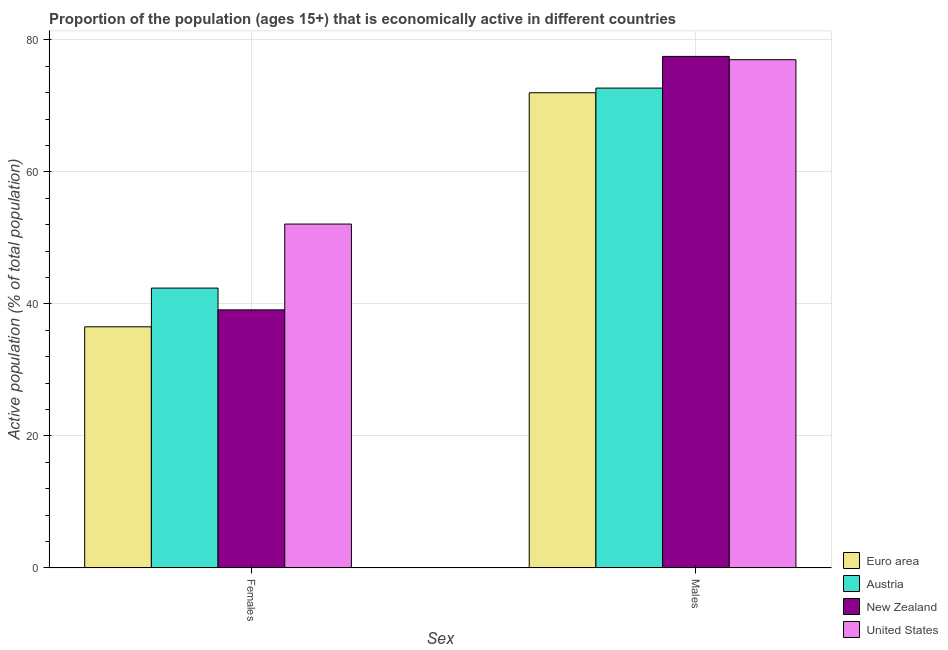How many different coloured bars are there?
Give a very brief answer. 4. How many bars are there on the 1st tick from the left?
Provide a short and direct response. 4. How many bars are there on the 2nd tick from the right?
Offer a terse response. 4. What is the label of the 1st group of bars from the left?
Make the answer very short. Females. What is the percentage of economically active female population in Euro area?
Your response must be concise. 36.53. Across all countries, what is the maximum percentage of economically active female population?
Make the answer very short. 52.1. Across all countries, what is the minimum percentage of economically active female population?
Keep it short and to the point. 36.53. What is the total percentage of economically active male population in the graph?
Make the answer very short. 299.19. What is the difference between the percentage of economically active male population in Euro area and that in New Zealand?
Give a very brief answer. -5.51. What is the difference between the percentage of economically active female population in United States and the percentage of economically active male population in Euro area?
Give a very brief answer. -19.89. What is the average percentage of economically active female population per country?
Make the answer very short. 42.53. What is the difference between the percentage of economically active male population and percentage of economically active female population in United States?
Your answer should be compact. 24.9. What is the ratio of the percentage of economically active female population in Euro area to that in Austria?
Give a very brief answer. 0.86. Is the percentage of economically active male population in United States less than that in New Zealand?
Your answer should be very brief. Yes. What does the 1st bar from the left in Males represents?
Your response must be concise. Euro area. What does the 1st bar from the right in Females represents?
Make the answer very short. United States. How many countries are there in the graph?
Make the answer very short. 4. What is the difference between two consecutive major ticks on the Y-axis?
Your response must be concise. 20. Are the values on the major ticks of Y-axis written in scientific E-notation?
Provide a short and direct response. No. Does the graph contain grids?
Offer a terse response. Yes. How many legend labels are there?
Your response must be concise. 4. How are the legend labels stacked?
Make the answer very short. Vertical. What is the title of the graph?
Offer a terse response. Proportion of the population (ages 15+) that is economically active in different countries. What is the label or title of the X-axis?
Provide a short and direct response. Sex. What is the label or title of the Y-axis?
Provide a short and direct response. Active population (% of total population). What is the Active population (% of total population) in Euro area in Females?
Your response must be concise. 36.53. What is the Active population (% of total population) of Austria in Females?
Ensure brevity in your answer.  42.4. What is the Active population (% of total population) of New Zealand in Females?
Make the answer very short. 39.1. What is the Active population (% of total population) of United States in Females?
Provide a succinct answer. 52.1. What is the Active population (% of total population) in Euro area in Males?
Ensure brevity in your answer.  71.99. What is the Active population (% of total population) in Austria in Males?
Make the answer very short. 72.7. What is the Active population (% of total population) in New Zealand in Males?
Provide a short and direct response. 77.5. What is the Active population (% of total population) of United States in Males?
Your response must be concise. 77. Across all Sex, what is the maximum Active population (% of total population) in Euro area?
Provide a succinct answer. 71.99. Across all Sex, what is the maximum Active population (% of total population) in Austria?
Your answer should be compact. 72.7. Across all Sex, what is the maximum Active population (% of total population) of New Zealand?
Offer a very short reply. 77.5. Across all Sex, what is the maximum Active population (% of total population) of United States?
Provide a short and direct response. 77. Across all Sex, what is the minimum Active population (% of total population) of Euro area?
Make the answer very short. 36.53. Across all Sex, what is the minimum Active population (% of total population) in Austria?
Keep it short and to the point. 42.4. Across all Sex, what is the minimum Active population (% of total population) of New Zealand?
Offer a very short reply. 39.1. Across all Sex, what is the minimum Active population (% of total population) of United States?
Your answer should be compact. 52.1. What is the total Active population (% of total population) of Euro area in the graph?
Offer a very short reply. 108.53. What is the total Active population (% of total population) in Austria in the graph?
Provide a short and direct response. 115.1. What is the total Active population (% of total population) in New Zealand in the graph?
Provide a short and direct response. 116.6. What is the total Active population (% of total population) of United States in the graph?
Offer a terse response. 129.1. What is the difference between the Active population (% of total population) in Euro area in Females and that in Males?
Keep it short and to the point. -35.46. What is the difference between the Active population (% of total population) in Austria in Females and that in Males?
Ensure brevity in your answer.  -30.3. What is the difference between the Active population (% of total population) of New Zealand in Females and that in Males?
Provide a succinct answer. -38.4. What is the difference between the Active population (% of total population) in United States in Females and that in Males?
Keep it short and to the point. -24.9. What is the difference between the Active population (% of total population) of Euro area in Females and the Active population (% of total population) of Austria in Males?
Provide a succinct answer. -36.17. What is the difference between the Active population (% of total population) in Euro area in Females and the Active population (% of total population) in New Zealand in Males?
Your response must be concise. -40.97. What is the difference between the Active population (% of total population) in Euro area in Females and the Active population (% of total population) in United States in Males?
Offer a very short reply. -40.47. What is the difference between the Active population (% of total population) of Austria in Females and the Active population (% of total population) of New Zealand in Males?
Ensure brevity in your answer.  -35.1. What is the difference between the Active population (% of total population) of Austria in Females and the Active population (% of total population) of United States in Males?
Keep it short and to the point. -34.6. What is the difference between the Active population (% of total population) of New Zealand in Females and the Active population (% of total population) of United States in Males?
Make the answer very short. -37.9. What is the average Active population (% of total population) of Euro area per Sex?
Your answer should be compact. 54.26. What is the average Active population (% of total population) of Austria per Sex?
Offer a terse response. 57.55. What is the average Active population (% of total population) in New Zealand per Sex?
Your response must be concise. 58.3. What is the average Active population (% of total population) of United States per Sex?
Your response must be concise. 64.55. What is the difference between the Active population (% of total population) of Euro area and Active population (% of total population) of Austria in Females?
Make the answer very short. -5.87. What is the difference between the Active population (% of total population) in Euro area and Active population (% of total population) in New Zealand in Females?
Your answer should be very brief. -2.57. What is the difference between the Active population (% of total population) of Euro area and Active population (% of total population) of United States in Females?
Keep it short and to the point. -15.57. What is the difference between the Active population (% of total population) of Austria and Active population (% of total population) of New Zealand in Females?
Your answer should be very brief. 3.3. What is the difference between the Active population (% of total population) in Austria and Active population (% of total population) in United States in Females?
Provide a short and direct response. -9.7. What is the difference between the Active population (% of total population) of Euro area and Active population (% of total population) of Austria in Males?
Your answer should be compact. -0.71. What is the difference between the Active population (% of total population) in Euro area and Active population (% of total population) in New Zealand in Males?
Ensure brevity in your answer.  -5.51. What is the difference between the Active population (% of total population) in Euro area and Active population (% of total population) in United States in Males?
Ensure brevity in your answer.  -5.01. What is the difference between the Active population (% of total population) of Austria and Active population (% of total population) of New Zealand in Males?
Ensure brevity in your answer.  -4.8. What is the ratio of the Active population (% of total population) in Euro area in Females to that in Males?
Your answer should be very brief. 0.51. What is the ratio of the Active population (% of total population) of Austria in Females to that in Males?
Your response must be concise. 0.58. What is the ratio of the Active population (% of total population) in New Zealand in Females to that in Males?
Make the answer very short. 0.5. What is the ratio of the Active population (% of total population) of United States in Females to that in Males?
Provide a succinct answer. 0.68. What is the difference between the highest and the second highest Active population (% of total population) in Euro area?
Provide a short and direct response. 35.46. What is the difference between the highest and the second highest Active population (% of total population) in Austria?
Offer a terse response. 30.3. What is the difference between the highest and the second highest Active population (% of total population) in New Zealand?
Offer a terse response. 38.4. What is the difference between the highest and the second highest Active population (% of total population) in United States?
Your answer should be compact. 24.9. What is the difference between the highest and the lowest Active population (% of total population) of Euro area?
Provide a succinct answer. 35.46. What is the difference between the highest and the lowest Active population (% of total population) of Austria?
Provide a short and direct response. 30.3. What is the difference between the highest and the lowest Active population (% of total population) in New Zealand?
Your answer should be very brief. 38.4. What is the difference between the highest and the lowest Active population (% of total population) in United States?
Make the answer very short. 24.9. 